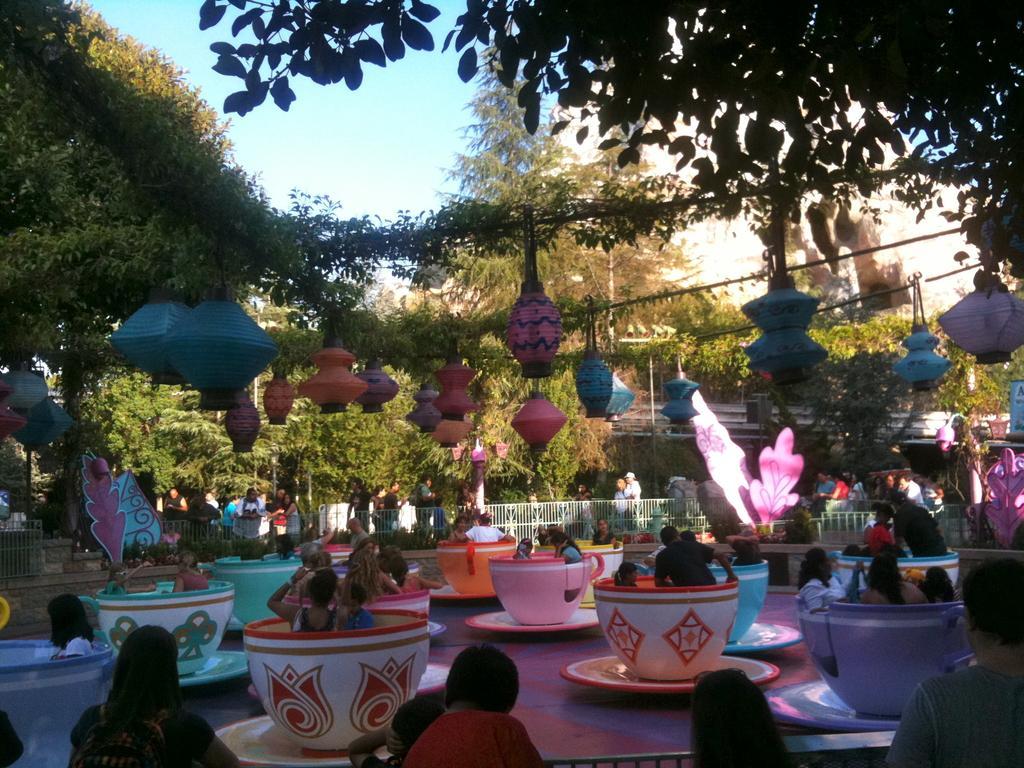In one or two sentences, can you explain what this image depicts? This picture describes about group of people, few are standing and few are seated in the cups, on top of them we can find few paper lanterns and cables, in the background we can see few poles, trees and fence. 